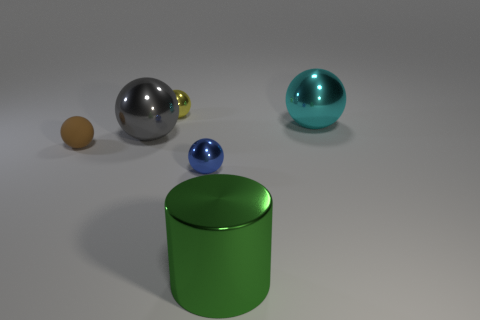Is there anything else that is made of the same material as the tiny brown ball?
Offer a terse response. No. There is a green thing that is the same material as the big cyan ball; what shape is it?
Keep it short and to the point. Cylinder. Are there fewer cyan balls on the left side of the tiny yellow shiny ball than big gray objects that are on the left side of the small brown ball?
Give a very brief answer. No. How many tiny things are cyan metallic objects or green shiny things?
Make the answer very short. 0. Do the small thing that is behind the cyan metal sphere and the green thing that is on the left side of the cyan object have the same shape?
Make the answer very short. No. What size is the metal ball on the left side of the small shiny object behind the big shiny object that is on the left side of the big green metal cylinder?
Offer a terse response. Large. There is a ball right of the blue object; how big is it?
Provide a succinct answer. Large. There is a tiny brown sphere on the left side of the blue metal ball; what is it made of?
Your answer should be very brief. Rubber. What number of yellow objects are either big metal balls or small rubber things?
Provide a short and direct response. 0. Is the tiny blue sphere made of the same material as the small sphere to the left of the small yellow shiny object?
Offer a very short reply. No. 